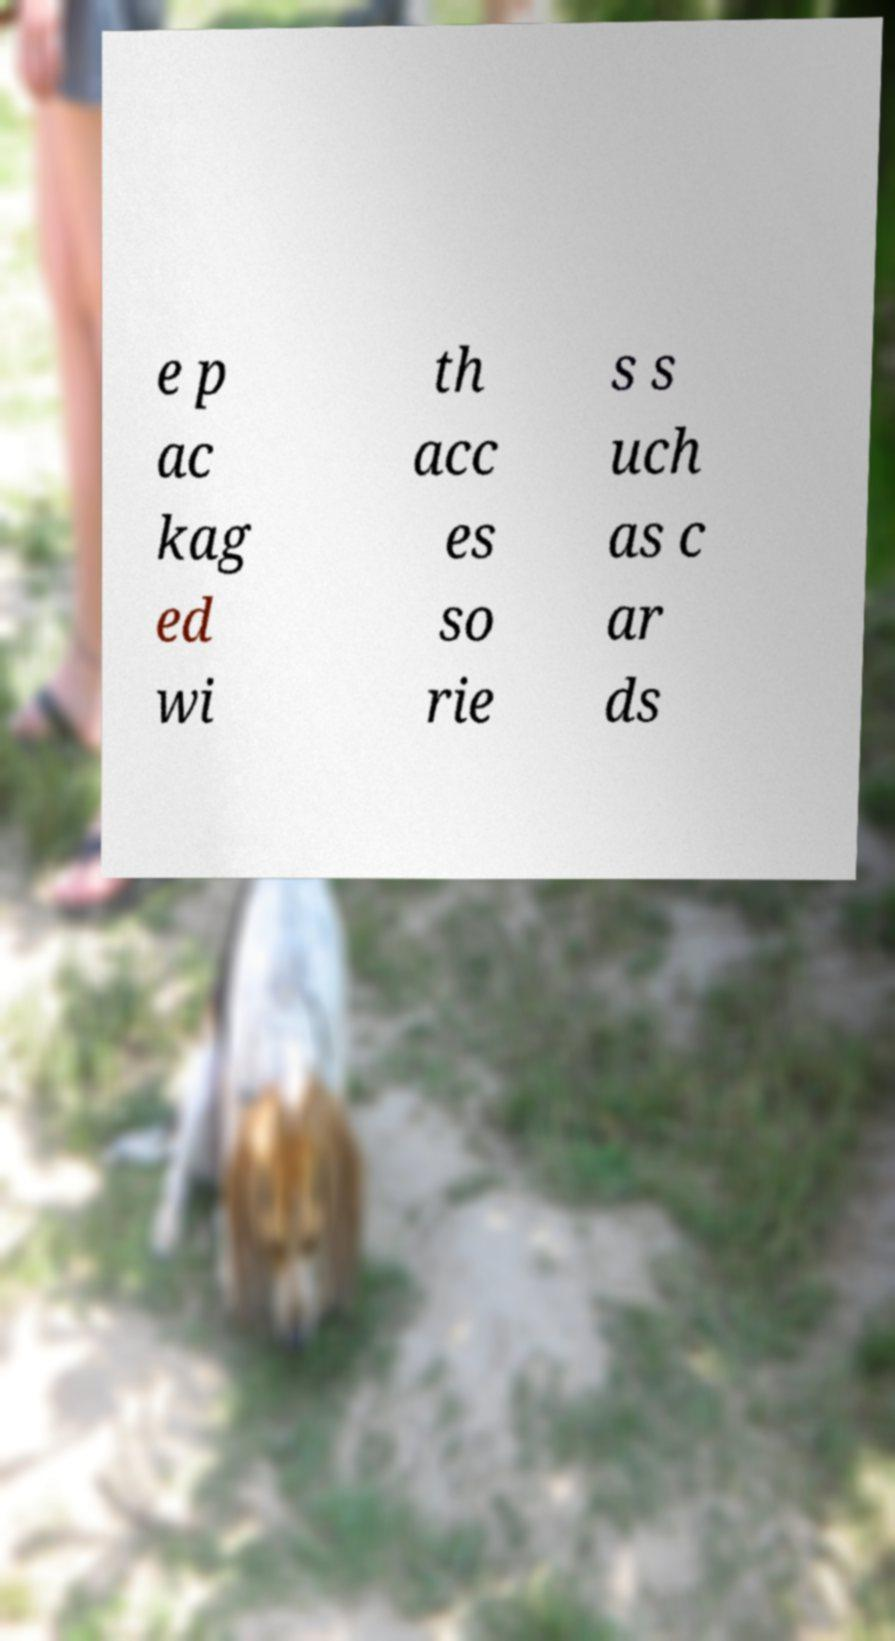Please read and relay the text visible in this image. What does it say? e p ac kag ed wi th acc es so rie s s uch as c ar ds 